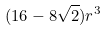<formula> <loc_0><loc_0><loc_500><loc_500>( 1 6 - 8 \sqrt { 2 } ) r ^ { 3 }</formula> 